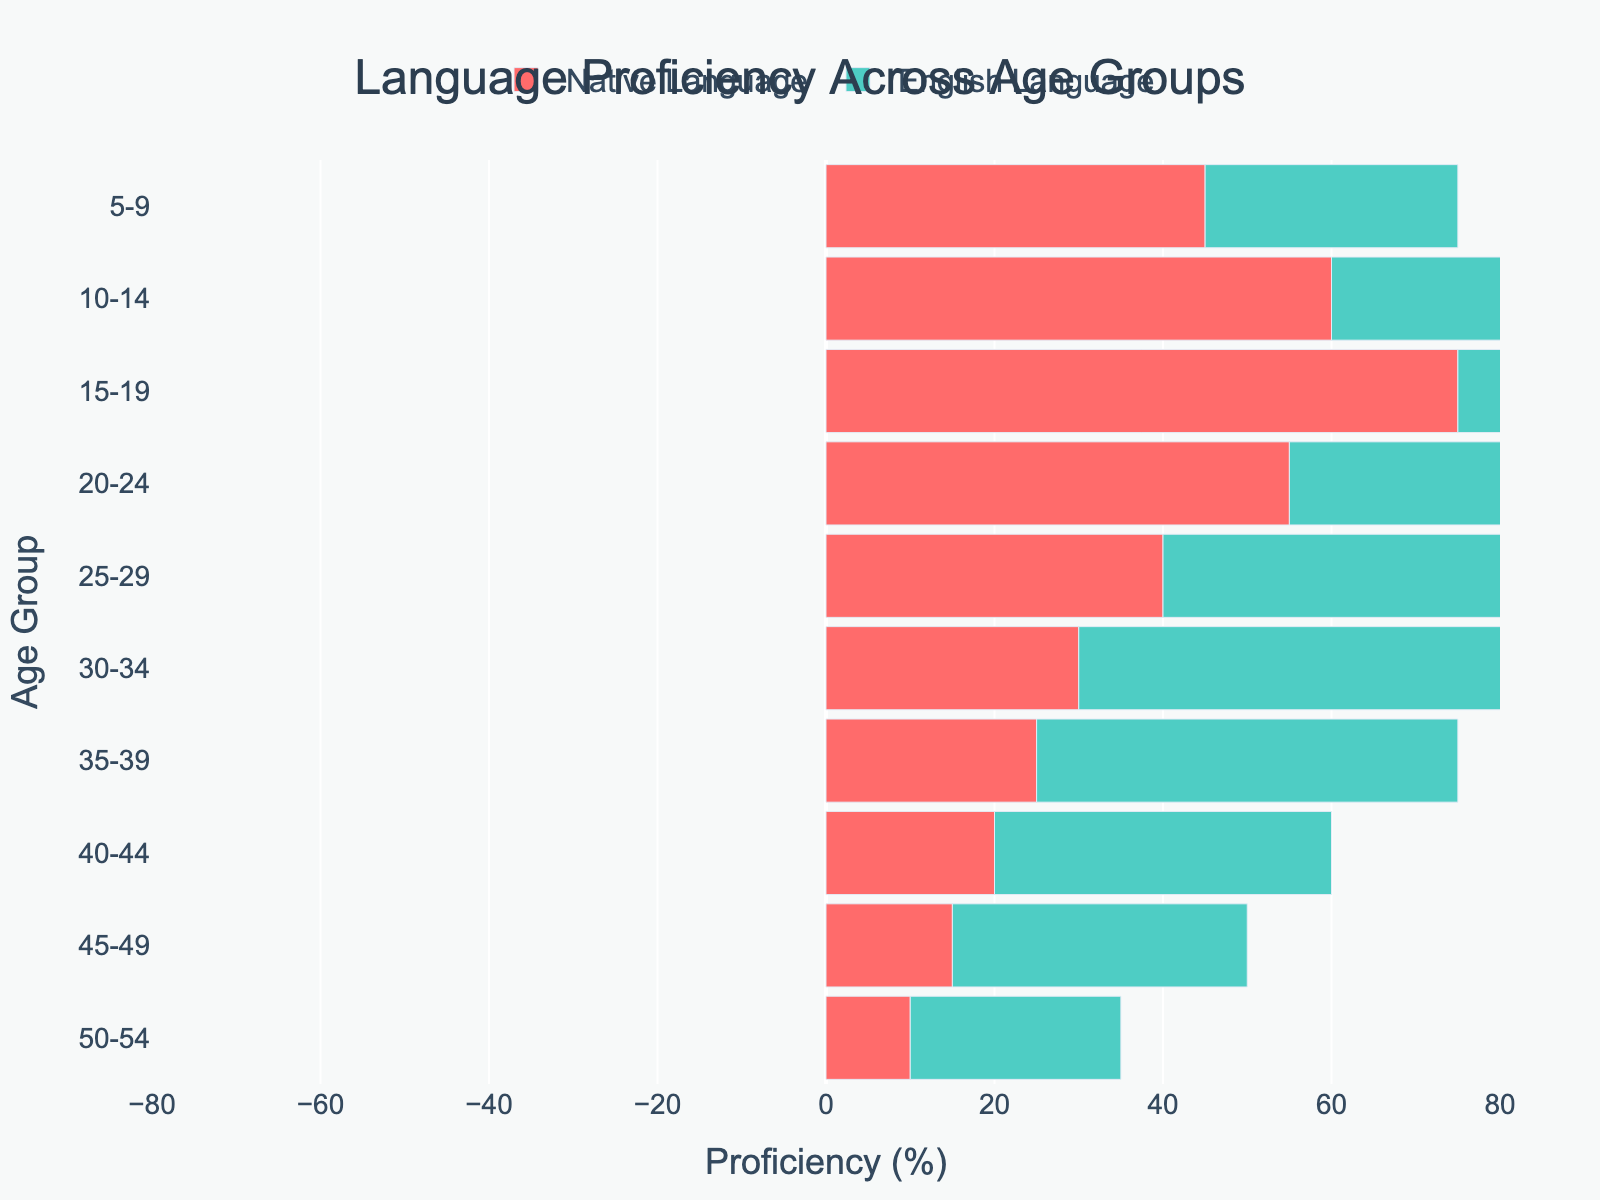What's the title of the figure? The title of the figure is displayed at the top and provides a brief description of what the figure is about.
Answer: Language Proficiency Across Age Groups What is the range of Native Language Proficiency for the age group 15-19? The bar for Native Language Proficiency in the age group 15-19 extends from 0 to -75%.
Answer: 0 to -75% Which age group has the highest English Language Proficiency? By comparing the lengths of the English Language Proficiency bars, the age group 25-29 has the longest bar reaching up to 75%.
Answer: 25-29 How does English Language Proficiency compare between the age groups 10-14 and 45-49? The bar for 10-14 extends to 45%, while the bar for 45-49 extends to 35%.
Answer: 10-14 is higher than 45-49 What's the general trend of Native Language Proficiency as age increases? By observing the lengths of the bars, Native Language Proficiency tends to decrease (less negative) as age increases. For example, it starts at -45% for 5-9 and decreases to -10% for 50-54.
Answer: Decreases Calculate the average English Language Proficiency for the age groups 20-24, 25-29, and 30-34. The English proficiencies are 70%, 75%, and 60%. Summing them gives 205% and dividing by 3 gives an average of 68.33%.
Answer: 68.33% Which age group shows the smallest difference between Native and English Language Proficiency? By calculating the differences for each age group, the age group 50-54 has a difference of 15% between 25% and -10%.
Answer: 50-54 How much more proficient in English is the 20-24 age group compared to the 5-9 age group? The English proficiency for 20-24 is 70% and for 5-9 is 30%, resulting in a difference of 40%.
Answer: 40% Describe the proficiency distribution for the 30-34 age group. In the 30-34 age group, Native Language Proficiency is at -30% and English Language Proficiency is at 60%, indicating a higher proficiency in English.
Answer: -30% Native, 60% English Which age group has the least proficiency in Native Language, and what's the value? The 15-19 age group has the least Native Language Proficiency with a value of -75%.
Answer: 15-19, -75% 